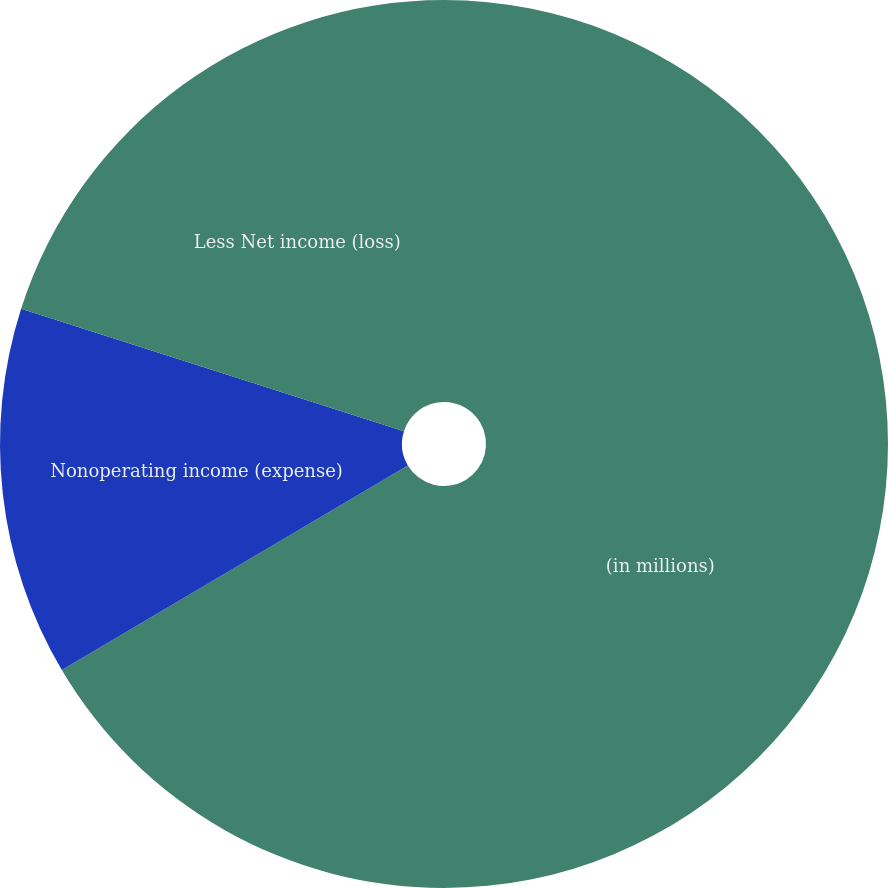Convert chart to OTSL. <chart><loc_0><loc_0><loc_500><loc_500><pie_chart><fcel>(in millions)<fcel>Nonoperating income (expense)<fcel>Less Net income (loss)<nl><fcel>66.5%<fcel>13.43%<fcel>20.07%<nl></chart> 